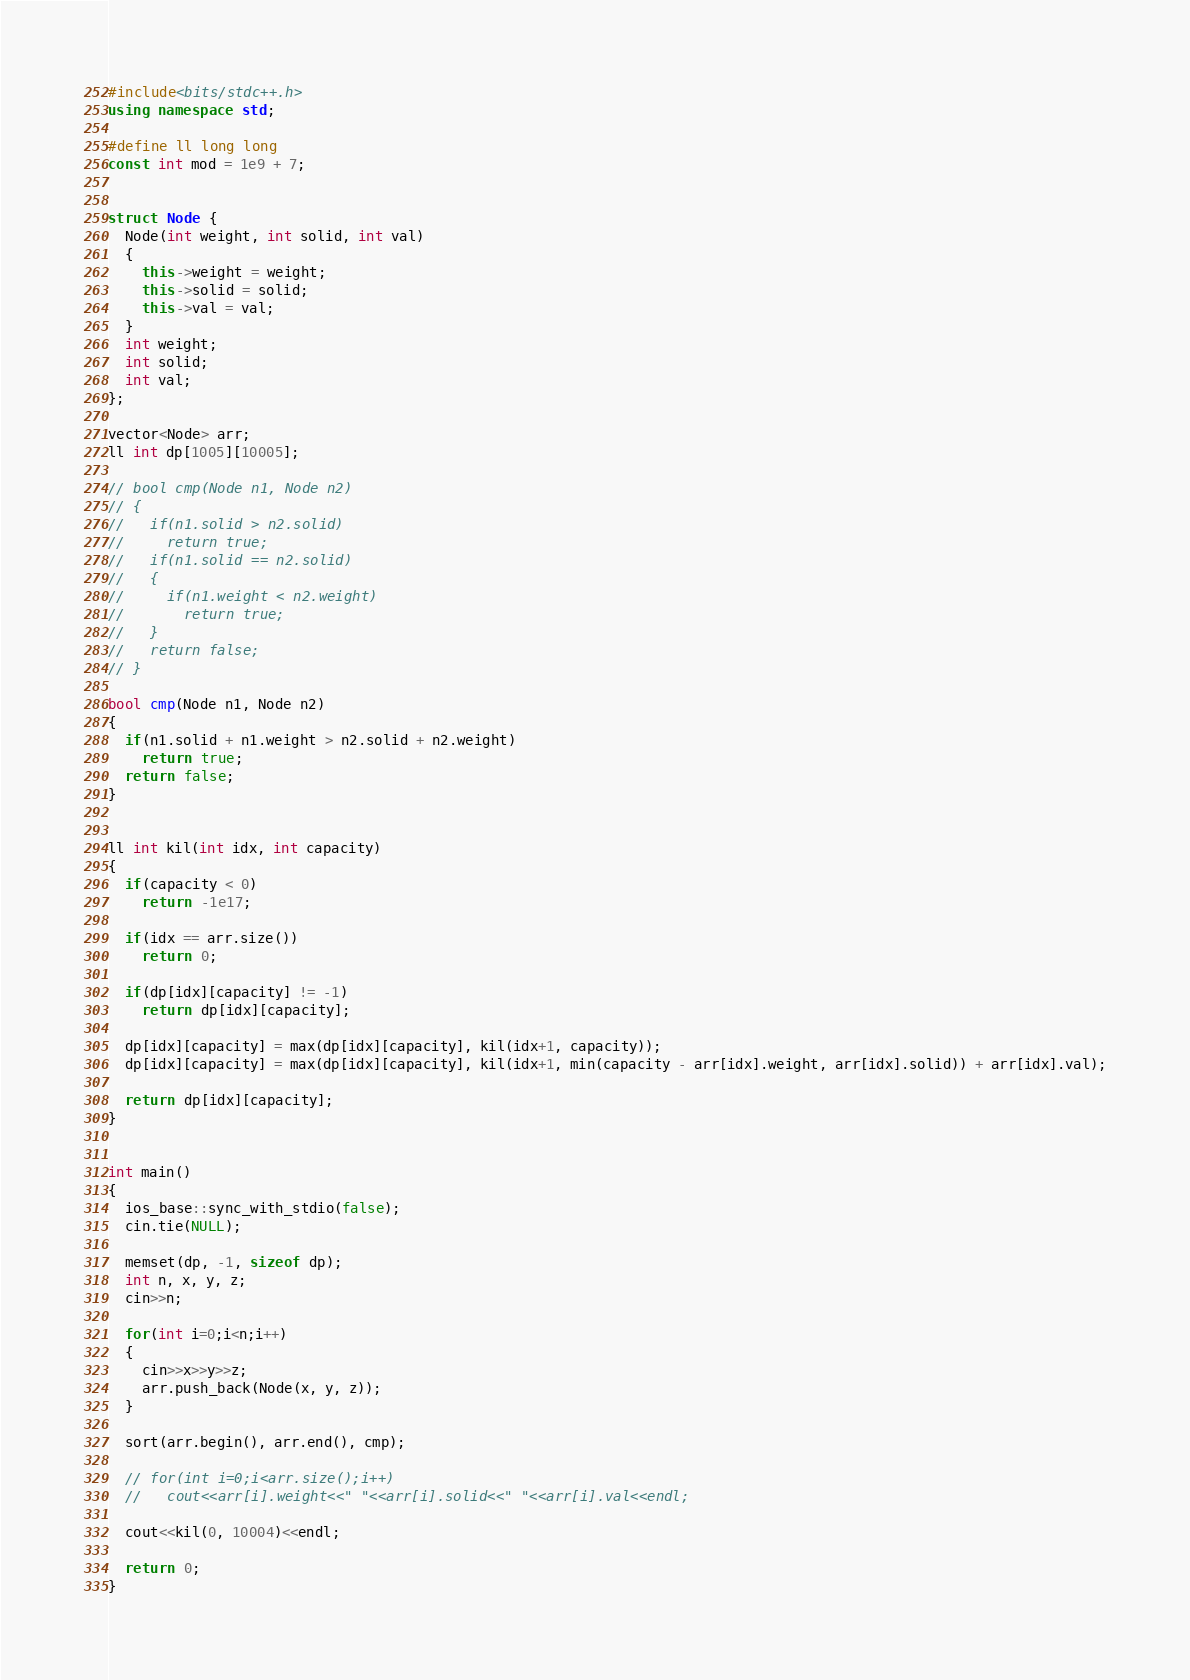<code> <loc_0><loc_0><loc_500><loc_500><_C++_>#include<bits/stdc++.h>
using namespace std;

#define ll long long
const int mod = 1e9 + 7;


struct Node {
  Node(int weight, int solid, int val)
  {
    this->weight = weight;
    this->solid = solid;
    this->val = val;
  }
  int weight;
  int solid;
  int val;
};

vector<Node> arr;
ll int dp[1005][10005];

// bool cmp(Node n1, Node n2)
// {
//   if(n1.solid > n2.solid)
//     return true;
//   if(n1.solid == n2.solid)
//   {
//     if(n1.weight < n2.weight)
//       return true;
//   }
//   return false;
// }

bool cmp(Node n1, Node n2)
{
  if(n1.solid + n1.weight > n2.solid + n2.weight)
    return true;
  return false;
}


ll int kil(int idx, int capacity)
{
  if(capacity < 0)
    return -1e17;

  if(idx == arr.size())
    return 0;

  if(dp[idx][capacity] != -1)
    return dp[idx][capacity];

  dp[idx][capacity] = max(dp[idx][capacity], kil(idx+1, capacity));
  dp[idx][capacity] = max(dp[idx][capacity], kil(idx+1, min(capacity - arr[idx].weight, arr[idx].solid)) + arr[idx].val);

  return dp[idx][capacity];
}


int main()
{
  ios_base::sync_with_stdio(false);
  cin.tie(NULL);

  memset(dp, -1, sizeof dp);
  int n, x, y, z;
  cin>>n;

  for(int i=0;i<n;i++)
  {
    cin>>x>>y>>z;
    arr.push_back(Node(x, y, z));
  }

  sort(arr.begin(), arr.end(), cmp);

  // for(int i=0;i<arr.size();i++)
  //   cout<<arr[i].weight<<" "<<arr[i].solid<<" "<<arr[i].val<<endl;

  cout<<kil(0, 10004)<<endl;

  return 0;
}
</code> 